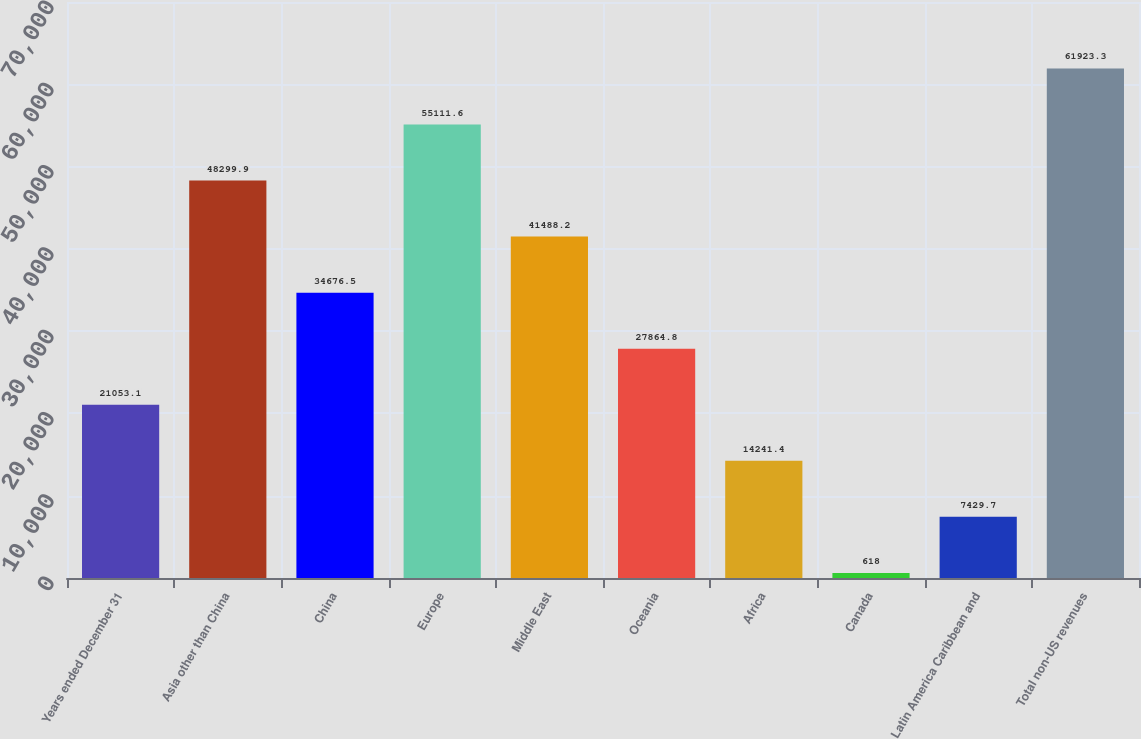<chart> <loc_0><loc_0><loc_500><loc_500><bar_chart><fcel>Years ended December 31<fcel>Asia other than China<fcel>China<fcel>Europe<fcel>Middle East<fcel>Oceania<fcel>Africa<fcel>Canada<fcel>Latin America Caribbean and<fcel>Total non-US revenues<nl><fcel>21053.1<fcel>48299.9<fcel>34676.5<fcel>55111.6<fcel>41488.2<fcel>27864.8<fcel>14241.4<fcel>618<fcel>7429.7<fcel>61923.3<nl></chart> 